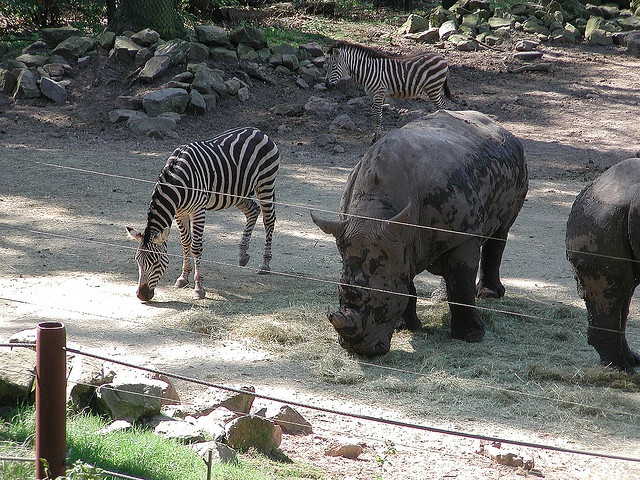Describe the objects in this image and their specific colors. I can see zebra in darkgreen, black, gray, darkgray, and lightgray tones and zebra in darkgreen, black, gray, and darkgray tones in this image. 